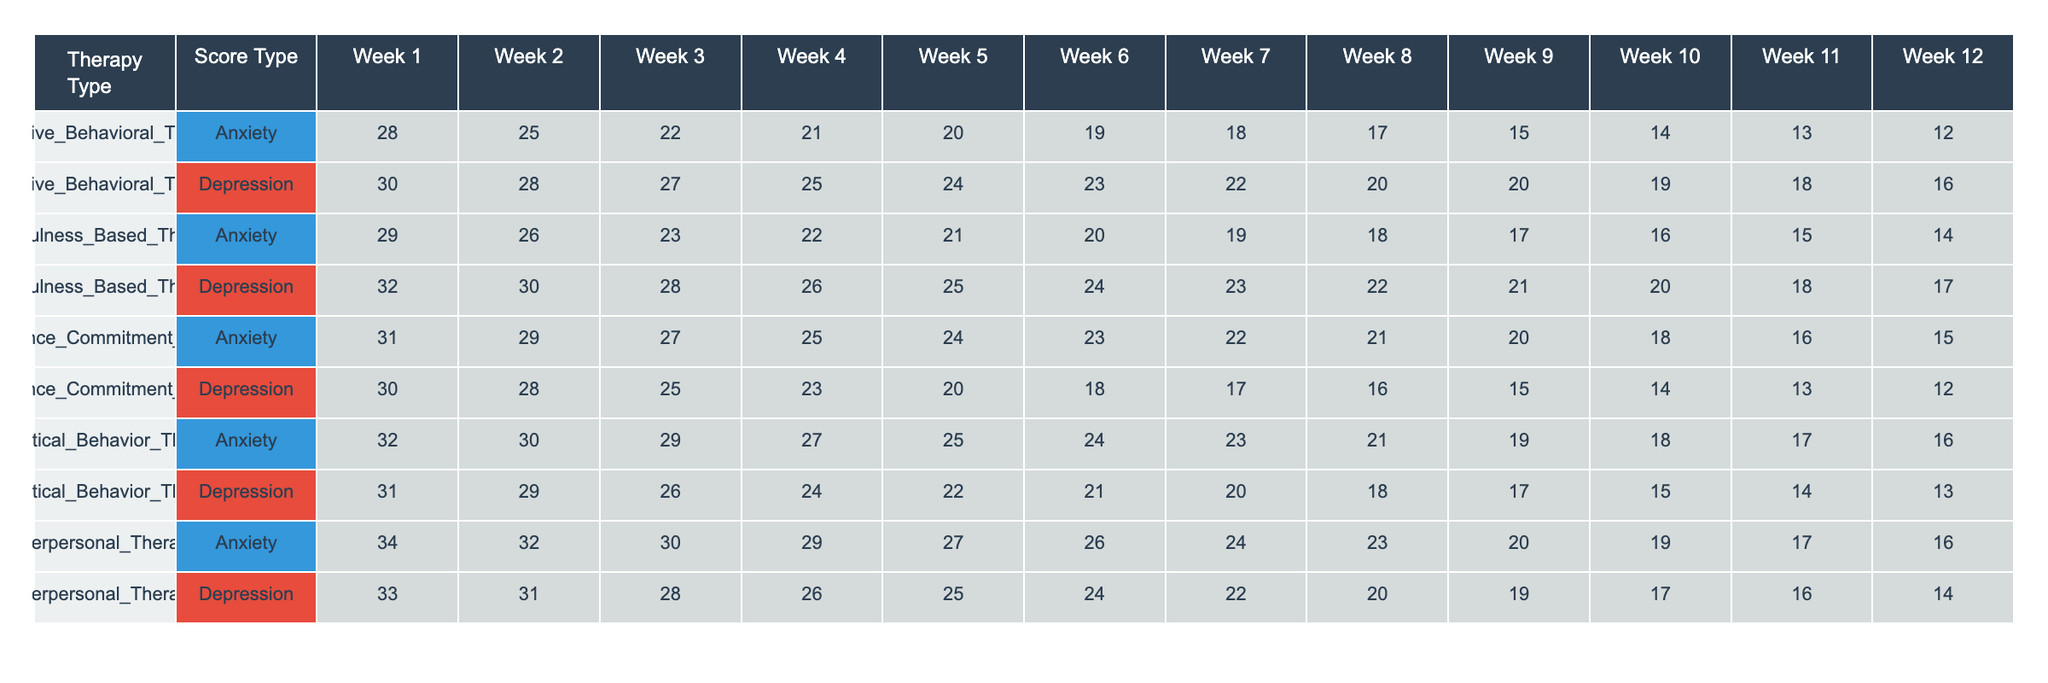What is the Week 1 Anxiety Score for Dialectical Behavior Therapy? According to the table, the Week 1 Anxiety Score for Dialectical Behavior Therapy is 32.
Answer: 32 Which therapy type has the lowest average Depression Score over the 12 weeks? To find the average Depression Score for each therapy, sum the scores for each type and divide by 12. The totals are: Cognitive Behavioral Therapy (20.25), Mindfulness Based Therapy (21.25), Acceptance Commitment Therapy (18.83), Dialectical Behavior Therapy (21.25), and Interpersonal Therapy (19.67). The lowest average is for Acceptance Commitment Therapy.
Answer: Acceptance Commitment Therapy What is the difference in Week 3 Anxiety Scores between Cognitive Behavioral Therapy and Acceptance Commitment Therapy? The Week 3 Anxiety Score for Cognitive Behavioral Therapy is 22 and for Acceptance Commitment Therapy is 23. The difference is 23 - 22 = 1.
Answer: 1 True or False: The Week 12 Depression Score for Interpersonal Therapy is higher than that for Mindfulness Based Therapy. The Week 12 Depression Score for Interpersonal Therapy is 14, while for Mindfulness Based Therapy it is 16. Since 14 is not higher than 16, the answer is False.
Answer: False What is the trend in Anxiety Scores for Mindfulness Based Therapy over the 12 weeks? We can observe the scores for each week for Mindfulness Based Therapy: 30, 28, 27, 25, 24, 23, 22, 20, 20, 19, 18, 16, which shows a downward trend. The scores consistently decrease from Week 1 to Week 12.
Answer: Downward trend Which therapy type shows the least reduction in weekly Depression Scores from Week 1 to Week 12? Calculating the difference in scores from Week 1 to Week 12 for each therapy gives the following reductions: CBT (18), Mindfulness (16), Acceptance (18), Dialectical (18), and Interpersonal (19). Mindfulness Based Therapy has the least reduction.
Answer: Mindfulness Based Therapy What is the average Anxiety Score for Week 5 across all therapy types? To find the average Anxiety Score for Week 5, we sum the Week 5 scores: 20 (CBT) + 24 (Mindfulness) + 21 (Acceptance) + 25 (Dialectical) + 24 (Interpersonal) = 114. There are 5 therapy types, so the average is 114 / 5 = 22.8.
Answer: 22.8 After Week 4, which therapy type consistently maintains a Depression Score below 20? Looking at the table, we see from Week 5, Acceptance Commitment Therapy maintains scores of 22, 20, 20, and 20. However, Dialectical Behavior Therapy also stays under 20 from Week 11 and 12. Therefore, the answer is both Acceptance Commitment Therapy and Dialectical Behavior Therapy.
Answer: Acceptance Commitment Therapy and Dialectical Behavior Therapy Which therapy type has the highest recorded Anxiety Score during Week 10? Checking the scores from the table, we find that Dialectical Behavior Therapy has the highest Anxiety Score of 20 during Week 10.
Answer: Dialectical Behavior Therapy 